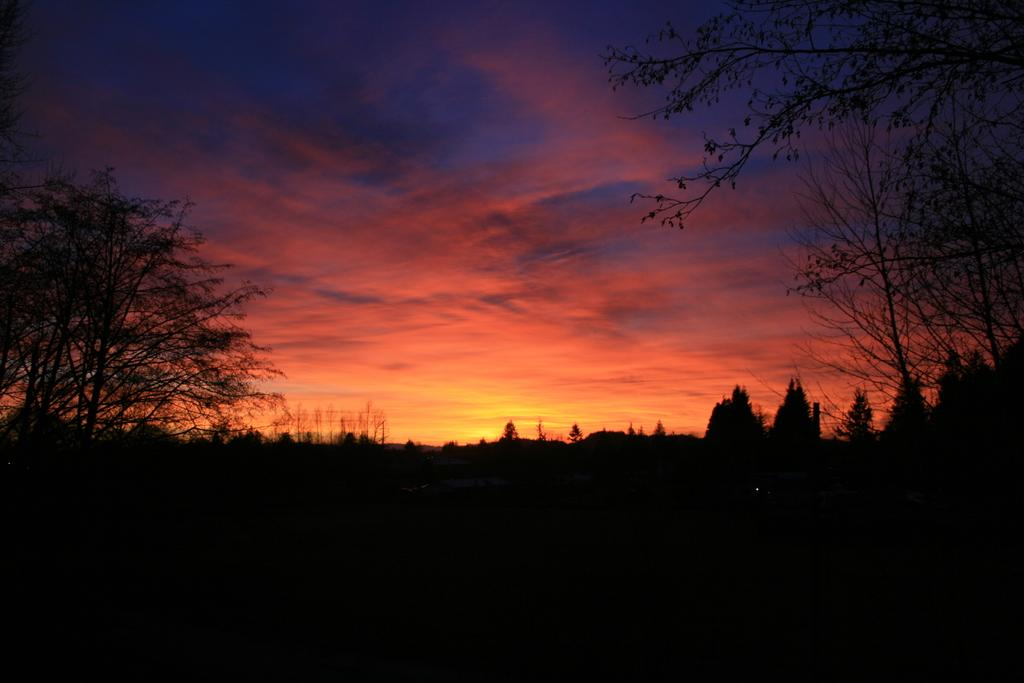What type of vegetation can be seen in the image? There are trees in the image. What is the color of the sky in the image? The sky is orange in color. Are there any weather phenomena visible in the sky? Clouds are present in the sky. What type of industry can be seen in the image? There is no industry present in the image; it features trees and an orange sky with clouds. Is there a hill visible in the image? There is no hill present in the image; it features trees and an orange sky with clouds. 